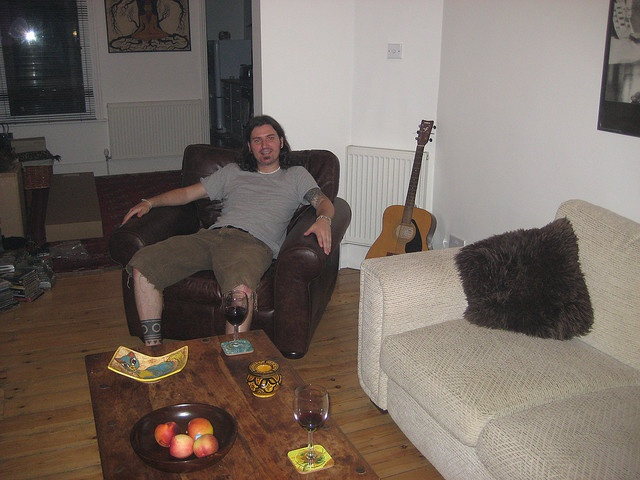Describe the objects in this image and their specific colors. I can see couch in black, darkgray, and gray tones, dining table in black, maroon, and brown tones, people in black and gray tones, chair in black and gray tones, and couch in black and gray tones in this image. 